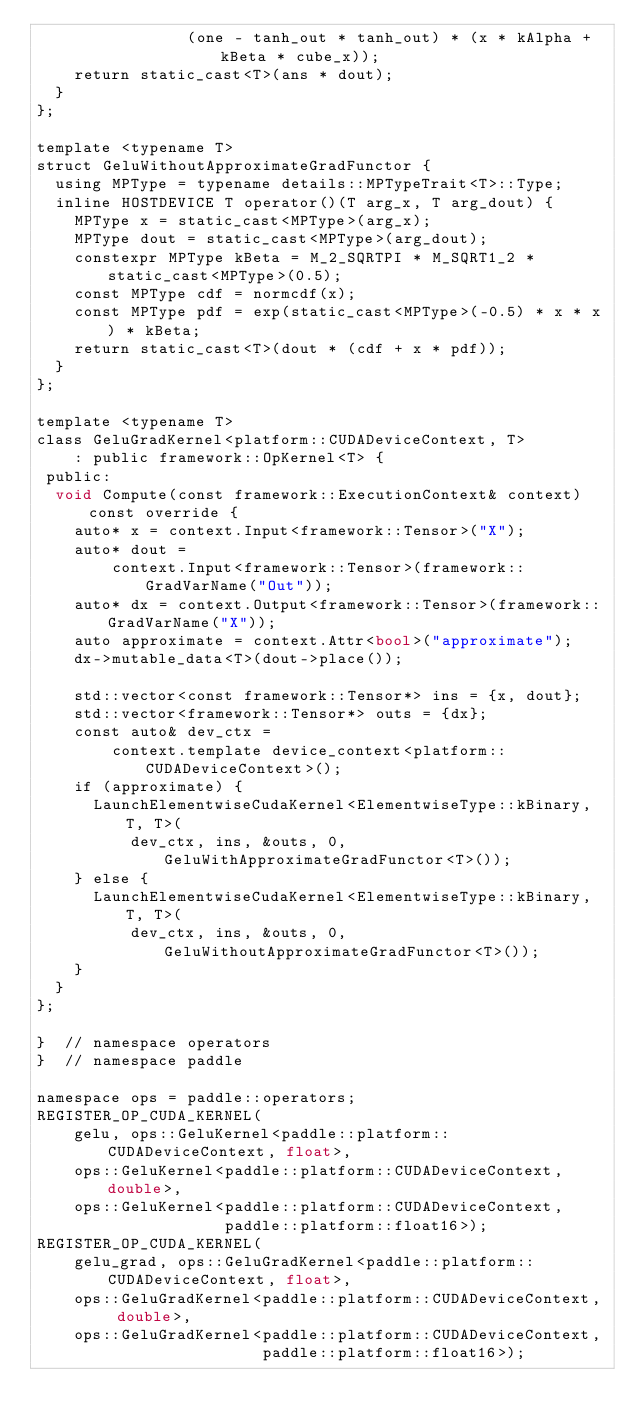Convert code to text. <code><loc_0><loc_0><loc_500><loc_500><_Cuda_>                (one - tanh_out * tanh_out) * (x * kAlpha + kBeta * cube_x));
    return static_cast<T>(ans * dout);
  }
};

template <typename T>
struct GeluWithoutApproximateGradFunctor {
  using MPType = typename details::MPTypeTrait<T>::Type;
  inline HOSTDEVICE T operator()(T arg_x, T arg_dout) {
    MPType x = static_cast<MPType>(arg_x);
    MPType dout = static_cast<MPType>(arg_dout);
    constexpr MPType kBeta = M_2_SQRTPI * M_SQRT1_2 * static_cast<MPType>(0.5);
    const MPType cdf = normcdf(x);
    const MPType pdf = exp(static_cast<MPType>(-0.5) * x * x) * kBeta;
    return static_cast<T>(dout * (cdf + x * pdf));
  }
};

template <typename T>
class GeluGradKernel<platform::CUDADeviceContext, T>
    : public framework::OpKernel<T> {
 public:
  void Compute(const framework::ExecutionContext& context) const override {
    auto* x = context.Input<framework::Tensor>("X");
    auto* dout =
        context.Input<framework::Tensor>(framework::GradVarName("Out"));
    auto* dx = context.Output<framework::Tensor>(framework::GradVarName("X"));
    auto approximate = context.Attr<bool>("approximate");
    dx->mutable_data<T>(dout->place());

    std::vector<const framework::Tensor*> ins = {x, dout};
    std::vector<framework::Tensor*> outs = {dx};
    const auto& dev_ctx =
        context.template device_context<platform::CUDADeviceContext>();
    if (approximate) {
      LaunchElementwiseCudaKernel<ElementwiseType::kBinary, T, T>(
          dev_ctx, ins, &outs, 0, GeluWithApproximateGradFunctor<T>());
    } else {
      LaunchElementwiseCudaKernel<ElementwiseType::kBinary, T, T>(
          dev_ctx, ins, &outs, 0, GeluWithoutApproximateGradFunctor<T>());
    }
  }
};

}  // namespace operators
}  // namespace paddle

namespace ops = paddle::operators;
REGISTER_OP_CUDA_KERNEL(
    gelu, ops::GeluKernel<paddle::platform::CUDADeviceContext, float>,
    ops::GeluKernel<paddle::platform::CUDADeviceContext, double>,
    ops::GeluKernel<paddle::platform::CUDADeviceContext,
                    paddle::platform::float16>);
REGISTER_OP_CUDA_KERNEL(
    gelu_grad, ops::GeluGradKernel<paddle::platform::CUDADeviceContext, float>,
    ops::GeluGradKernel<paddle::platform::CUDADeviceContext, double>,
    ops::GeluGradKernel<paddle::platform::CUDADeviceContext,
                        paddle::platform::float16>);
</code> 